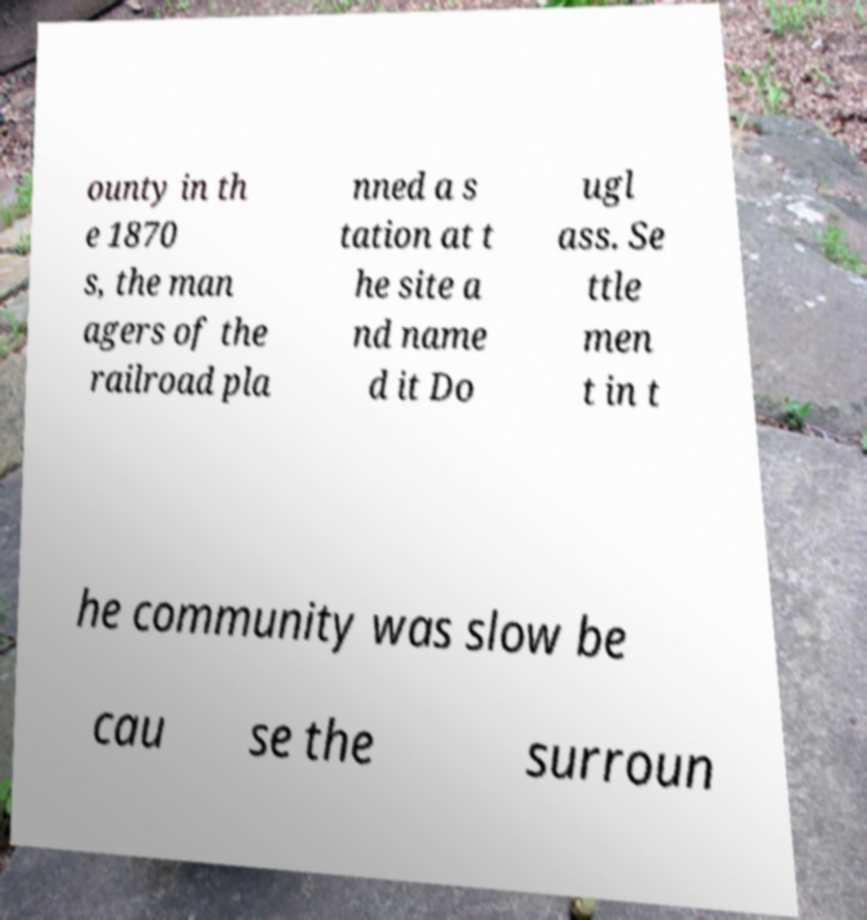Please read and relay the text visible in this image. What does it say? ounty in th e 1870 s, the man agers of the railroad pla nned a s tation at t he site a nd name d it Do ugl ass. Se ttle men t in t he community was slow be cau se the surroun 